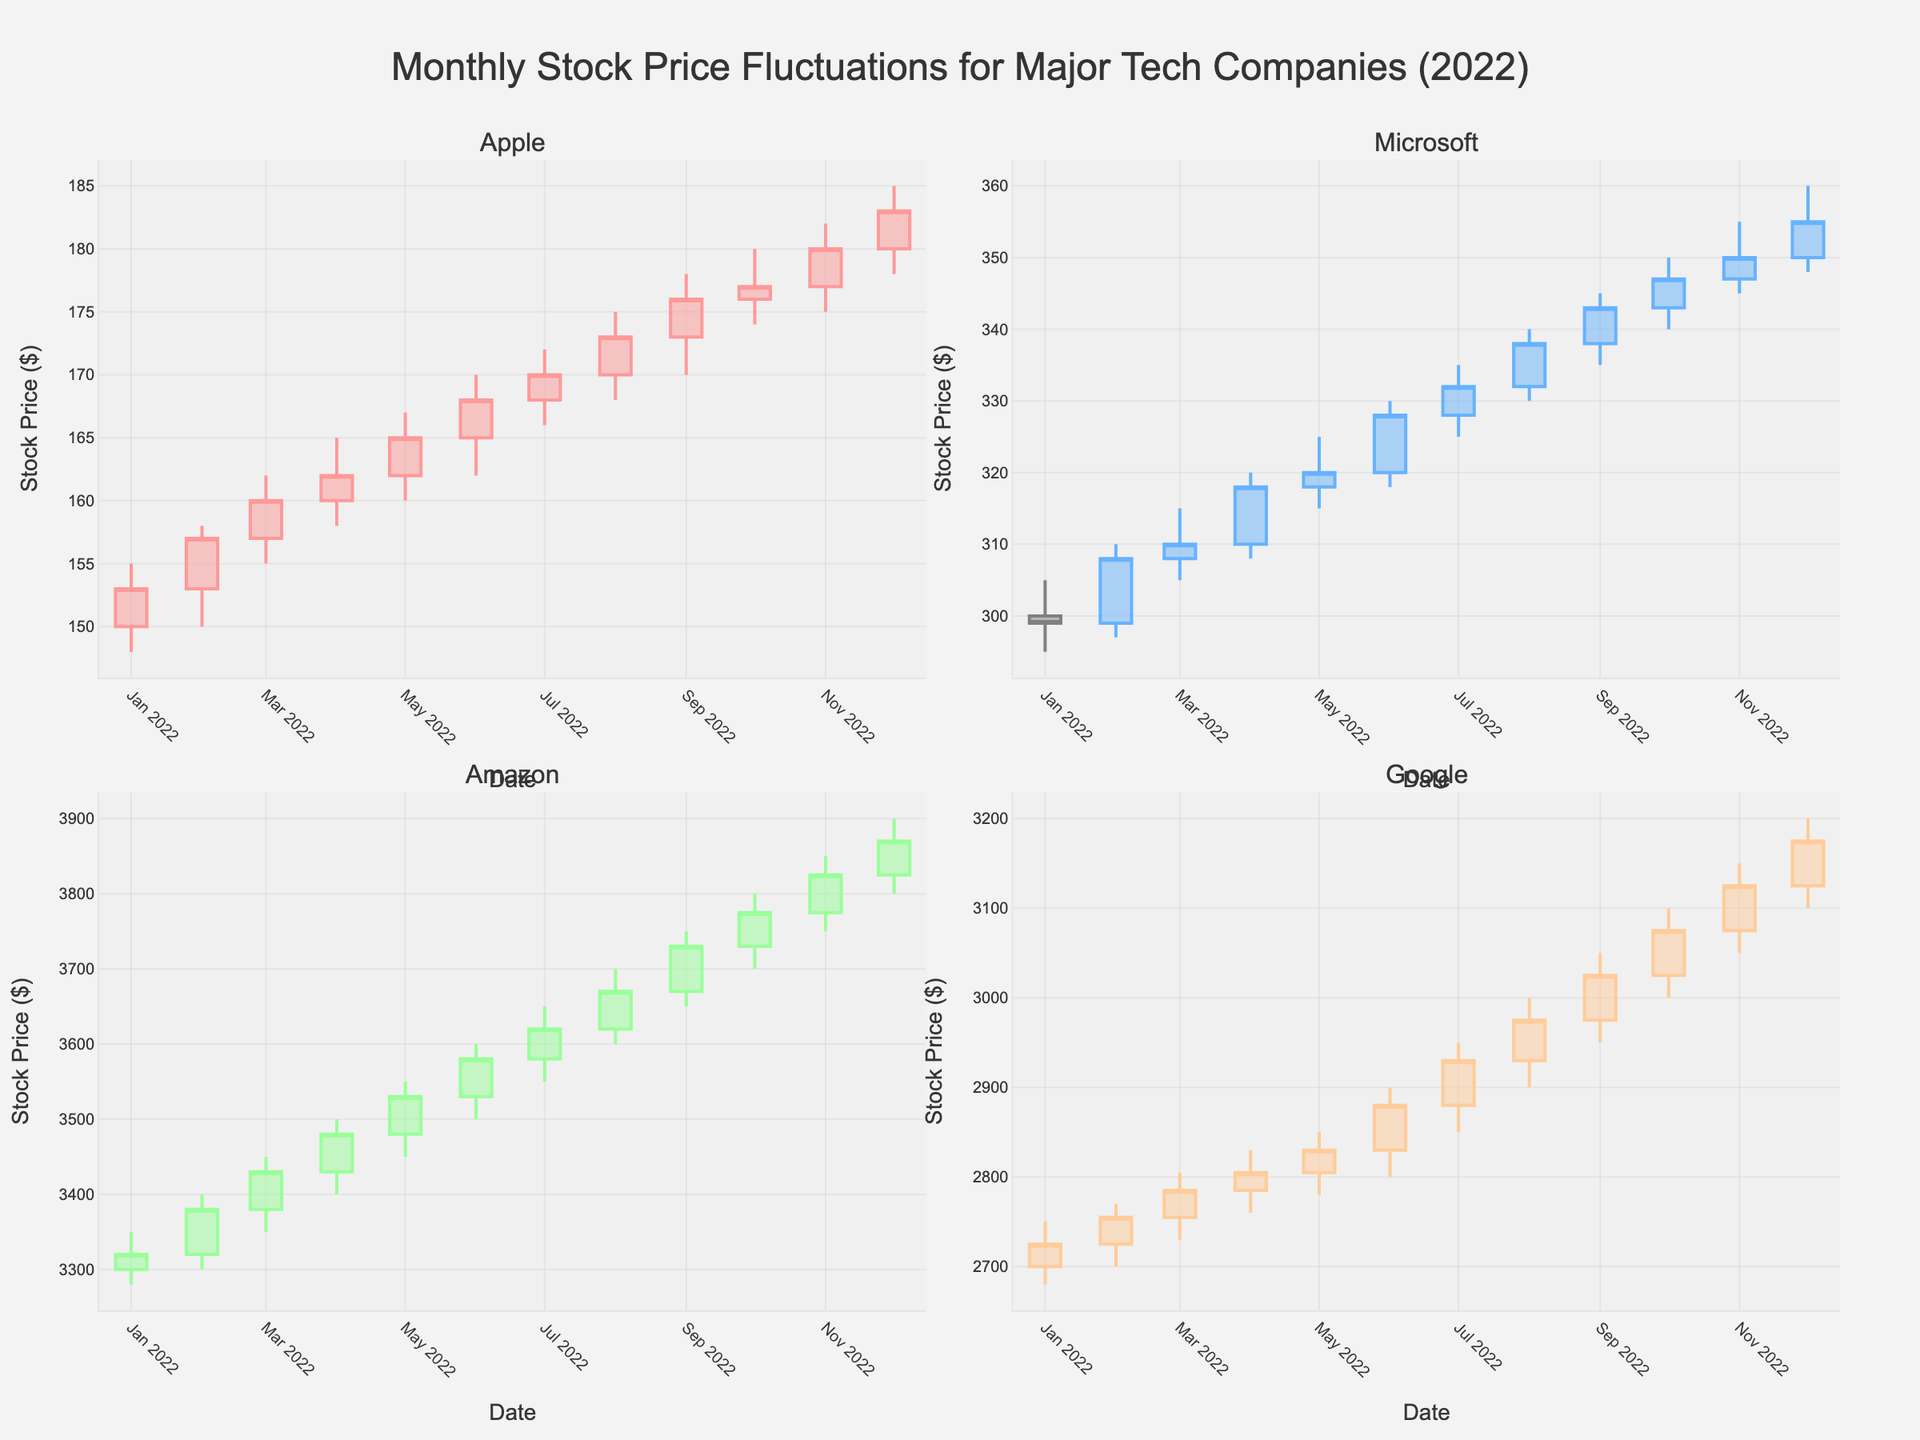What is the title of the figure? The title is usually located above the plot and summarizes the main topic of the visualization. Here, it is "Monthly Stock Price Fluctuations for Major Tech Companies (2022)."
Answer: Monthly Stock Price Fluctuations for Major Tech Companies (2022) Which company has the highest closing price in December 2022? Look at the candlestick for December 2022 for all companies and compare their closing prices. The highest closing price is for Amazon at $3870.00
Answer: Amazon How did the stock price of Apple change from January to December? Identify the opening price in January ($150.00) and the closing price in December ($183.00). The change is $183.00 - $150.00 = $33.00 increase.
Answer: Increased by $33.00 Which month did Google have its highest closing price? Observe the closing prices for each month for Google. The maximum closing price is in December at $3175.00.
Answer: December Compare the stock price trends of Microsoft and Apple over the year. Which one showed more growth? Calculate the difference between the December and January closing prices for both companies. Apple went from $153.00 to $183.00, a $30.00 increase. Microsoft went from $299.00 to $355.00, a $56.00 increase. Therefore, Microsoft showed more growth.
Answer: Microsoft During which month did Amazon's stock price see the largest monthly increase? Calculate the monthly increases by comparing the closing price of each month to the previous month's closing price. The largest increase is from January ($3320.00) to February ($3380.00), with an increase of $60.00.
Answer: February What is the trend of Apple's stock price from July to October? Examine the closing prices from July ($170.00) to October ($177.00). The trend shows a consistent increase each month.
Answer: Increasing If you compare the highest closing prices of all four companies in July, which company had the lowest? Compare the July closing prices for Apple ($170.00), Microsoft ($332.00), Amazon ($3620.00), and Google ($2930.00). The lowest is Apple at $170.00.
Answer: Apple For which company is the range between the highest and lowest prices the smallest in March 2022? Calculate the range (high-low) for each company in March. Apple: ($162.00 - $155.00 = $7.00), Microsoft: ($315.00 - $305.00 = $10.00), Amazon: ($3450.00 - $3350.00 = $100.00), Google: ($2805.00 - $2730.00 = $75.00). The smallest range is for Apple with $7.00.
Answer: Apple 